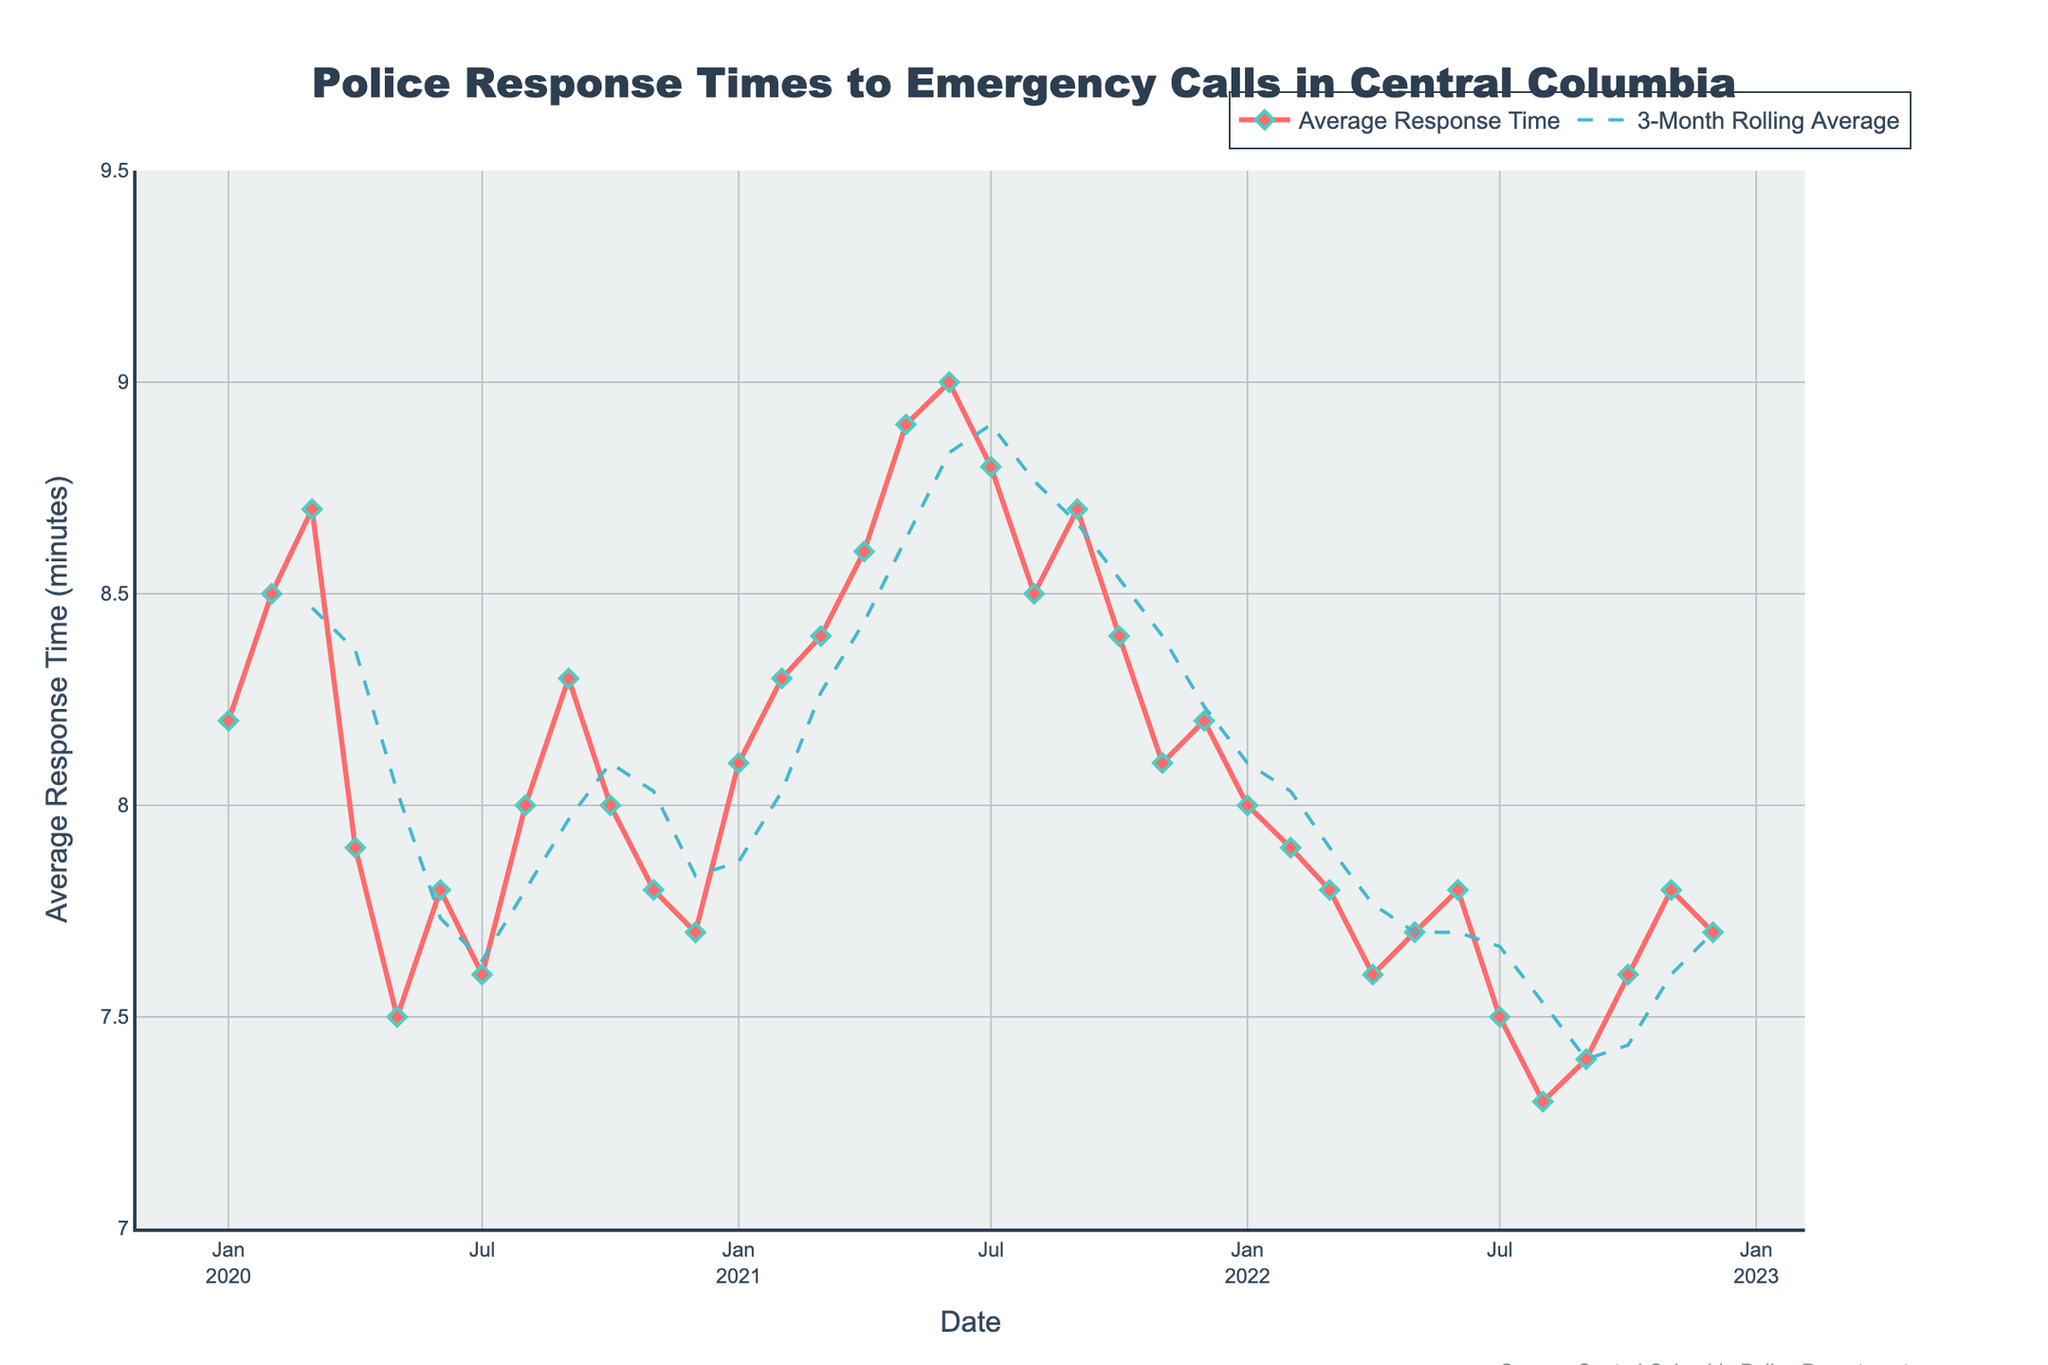What is the title of the plot? The title is displayed at the top of the plot and gives an overview of what the plot represents. The title reads “Police Response Times to Emergency Calls in Central Columbia.”
Answer: Police Response Times to Emergency Calls in Central Columbia What is the range of the y-axis? The y-axis on the right side has marks that show its range. It starts at 7 minutes and goes up to 9.5 minutes.
Answer: 7 to 9.5 minutes How many data points are there in total? By counting the number of markers on the plot, it shows there are 36 data points, one for each month from January 2020 to December 2022.
Answer: 36 What is the average response time for August 2021? Locate the marker for August 2021 on the x-axis and check the corresponding y-value. The average response time for August 2021 is 8.5 minutes.
Answer: 8.5 minutes Which month had the highest average response time and how much was it? By observing the peaks in the plot, May 2021 had the highest point on the y-axis, which was 9.0 minutes.
Answer: May 2021, 9.0 minutes How did the average response time change from January 2020 to January 2021? The average response time for January 2020 was 8.2 minutes and for January 2021 was 8.1 minutes, showing a decrease of 0.1 minutes.
Answer: Decreased by 0.1 minutes Which year had the overall lowest average response times based on visual inspection? By comparing the overall positions of points for each year, 2022 had more lower average response times than other years, particularly noticeable in the latter half of the year.
Answer: 2022 What is the trend of the 3-month rolling average in 2020? The 3-month rolling average line in 2020 starts from a mid-point, dips slightly in the middle of the year, recovers around September, and finally descends towards the end of the year. This shows a general decrease over 2020.
Answer: Decreasing What was the average response time trend in the first half of 2022 compared to the second half? In the first half of 2022, the average response time was relatively stable, mostly between 7.6 and 8.0 minutes. In the second half, it shows more variability but tends to be around 7.6 minutes. Thus, it was slightly decreasing.
Answer: Slightly decreasing What is the color of the line marking the 3-month rolling average? The color of the 3-month rolling average line is blue with a dashed pattern.
Answer: Blue 